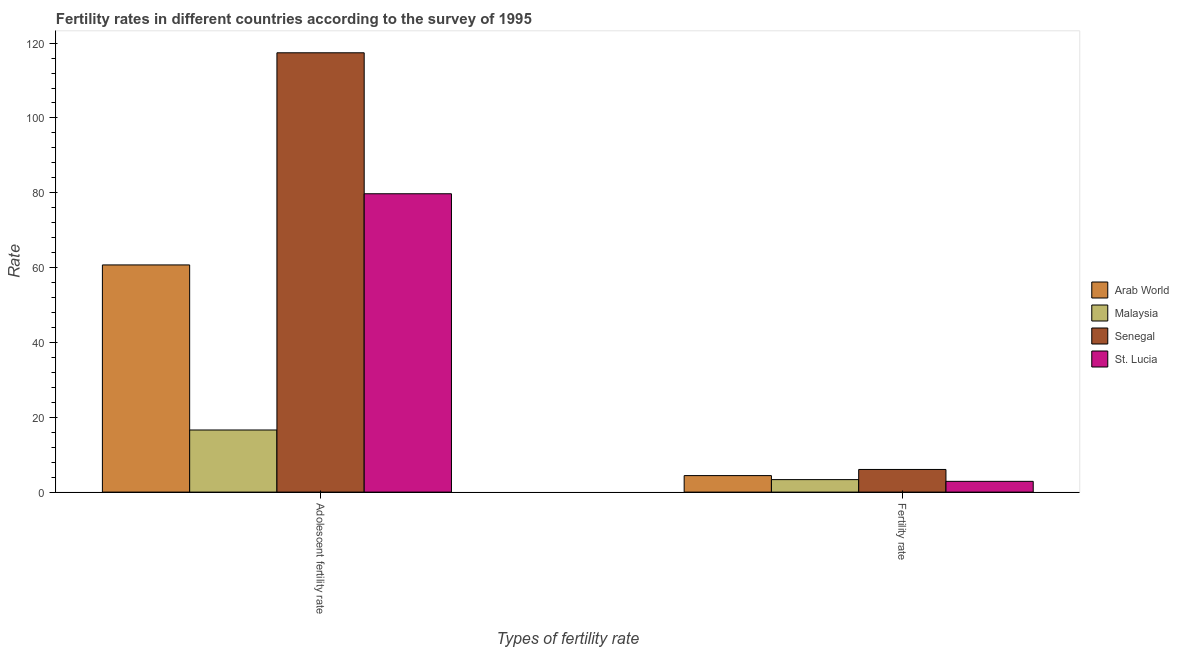How many groups of bars are there?
Your answer should be very brief. 2. Are the number of bars per tick equal to the number of legend labels?
Your answer should be very brief. Yes. How many bars are there on the 1st tick from the left?
Provide a short and direct response. 4. How many bars are there on the 1st tick from the right?
Offer a terse response. 4. What is the label of the 1st group of bars from the left?
Offer a terse response. Adolescent fertility rate. What is the adolescent fertility rate in Arab World?
Offer a very short reply. 60.72. Across all countries, what is the maximum fertility rate?
Offer a terse response. 6.05. Across all countries, what is the minimum adolescent fertility rate?
Make the answer very short. 16.6. In which country was the adolescent fertility rate maximum?
Ensure brevity in your answer.  Senegal. In which country was the fertility rate minimum?
Your response must be concise. St. Lucia. What is the total adolescent fertility rate in the graph?
Keep it short and to the point. 274.46. What is the difference between the adolescent fertility rate in St. Lucia and that in Malaysia?
Give a very brief answer. 63.13. What is the difference between the fertility rate in Senegal and the adolescent fertility rate in Malaysia?
Your answer should be compact. -10.55. What is the average fertility rate per country?
Give a very brief answer. 4.17. What is the difference between the adolescent fertility rate and fertility rate in St. Lucia?
Give a very brief answer. 76.86. In how many countries, is the fertility rate greater than 116 ?
Your answer should be compact. 0. What is the ratio of the fertility rate in Senegal to that in St. Lucia?
Make the answer very short. 2.11. In how many countries, is the adolescent fertility rate greater than the average adolescent fertility rate taken over all countries?
Keep it short and to the point. 2. What does the 2nd bar from the left in Fertility rate represents?
Offer a very short reply. Malaysia. What does the 2nd bar from the right in Fertility rate represents?
Provide a succinct answer. Senegal. How many bars are there?
Your answer should be compact. 8. Are all the bars in the graph horizontal?
Provide a short and direct response. No. How many countries are there in the graph?
Offer a terse response. 4. Does the graph contain any zero values?
Your answer should be very brief. No. Does the graph contain grids?
Your response must be concise. No. Where does the legend appear in the graph?
Provide a succinct answer. Center right. How many legend labels are there?
Provide a short and direct response. 4. What is the title of the graph?
Make the answer very short. Fertility rates in different countries according to the survey of 1995. Does "Equatorial Guinea" appear as one of the legend labels in the graph?
Your response must be concise. No. What is the label or title of the X-axis?
Provide a succinct answer. Types of fertility rate. What is the label or title of the Y-axis?
Your answer should be very brief. Rate. What is the Rate in Arab World in Adolescent fertility rate?
Provide a short and direct response. 60.72. What is the Rate of Malaysia in Adolescent fertility rate?
Keep it short and to the point. 16.6. What is the Rate in Senegal in Adolescent fertility rate?
Your answer should be compact. 117.41. What is the Rate in St. Lucia in Adolescent fertility rate?
Keep it short and to the point. 79.73. What is the Rate of Arab World in Fertility rate?
Your answer should be compact. 4.41. What is the Rate in Malaysia in Fertility rate?
Your answer should be very brief. 3.34. What is the Rate of Senegal in Fertility rate?
Your answer should be very brief. 6.05. What is the Rate in St. Lucia in Fertility rate?
Keep it short and to the point. 2.87. Across all Types of fertility rate, what is the maximum Rate in Arab World?
Make the answer very short. 60.72. Across all Types of fertility rate, what is the maximum Rate in Malaysia?
Offer a very short reply. 16.6. Across all Types of fertility rate, what is the maximum Rate in Senegal?
Offer a terse response. 117.41. Across all Types of fertility rate, what is the maximum Rate of St. Lucia?
Ensure brevity in your answer.  79.73. Across all Types of fertility rate, what is the minimum Rate in Arab World?
Offer a terse response. 4.41. Across all Types of fertility rate, what is the minimum Rate of Malaysia?
Your answer should be compact. 3.34. Across all Types of fertility rate, what is the minimum Rate of Senegal?
Keep it short and to the point. 6.05. Across all Types of fertility rate, what is the minimum Rate of St. Lucia?
Offer a terse response. 2.87. What is the total Rate of Arab World in the graph?
Provide a succinct answer. 65.12. What is the total Rate of Malaysia in the graph?
Ensure brevity in your answer.  19.94. What is the total Rate of Senegal in the graph?
Offer a terse response. 123.46. What is the total Rate in St. Lucia in the graph?
Offer a very short reply. 82.61. What is the difference between the Rate in Arab World in Adolescent fertility rate and that in Fertility rate?
Offer a terse response. 56.31. What is the difference between the Rate in Malaysia in Adolescent fertility rate and that in Fertility rate?
Your answer should be very brief. 13.26. What is the difference between the Rate of Senegal in Adolescent fertility rate and that in Fertility rate?
Provide a short and direct response. 111.36. What is the difference between the Rate in St. Lucia in Adolescent fertility rate and that in Fertility rate?
Provide a short and direct response. 76.86. What is the difference between the Rate in Arab World in Adolescent fertility rate and the Rate in Malaysia in Fertility rate?
Give a very brief answer. 57.38. What is the difference between the Rate in Arab World in Adolescent fertility rate and the Rate in Senegal in Fertility rate?
Provide a succinct answer. 54.66. What is the difference between the Rate of Arab World in Adolescent fertility rate and the Rate of St. Lucia in Fertility rate?
Offer a terse response. 57.84. What is the difference between the Rate of Malaysia in Adolescent fertility rate and the Rate of Senegal in Fertility rate?
Your answer should be very brief. 10.55. What is the difference between the Rate of Malaysia in Adolescent fertility rate and the Rate of St. Lucia in Fertility rate?
Provide a short and direct response. 13.73. What is the difference between the Rate in Senegal in Adolescent fertility rate and the Rate in St. Lucia in Fertility rate?
Make the answer very short. 114.54. What is the average Rate of Arab World per Types of fertility rate?
Provide a succinct answer. 32.56. What is the average Rate in Malaysia per Types of fertility rate?
Your answer should be very brief. 9.97. What is the average Rate in Senegal per Types of fertility rate?
Offer a very short reply. 61.73. What is the average Rate in St. Lucia per Types of fertility rate?
Your answer should be very brief. 41.3. What is the difference between the Rate in Arab World and Rate in Malaysia in Adolescent fertility rate?
Your response must be concise. 44.12. What is the difference between the Rate in Arab World and Rate in Senegal in Adolescent fertility rate?
Your response must be concise. -56.69. What is the difference between the Rate of Arab World and Rate of St. Lucia in Adolescent fertility rate?
Make the answer very short. -19.02. What is the difference between the Rate of Malaysia and Rate of Senegal in Adolescent fertility rate?
Your response must be concise. -100.81. What is the difference between the Rate in Malaysia and Rate in St. Lucia in Adolescent fertility rate?
Make the answer very short. -63.13. What is the difference between the Rate of Senegal and Rate of St. Lucia in Adolescent fertility rate?
Offer a very short reply. 37.68. What is the difference between the Rate in Arab World and Rate in Malaysia in Fertility rate?
Give a very brief answer. 1.07. What is the difference between the Rate of Arab World and Rate of Senegal in Fertility rate?
Your answer should be compact. -1.64. What is the difference between the Rate of Arab World and Rate of St. Lucia in Fertility rate?
Offer a terse response. 1.54. What is the difference between the Rate in Malaysia and Rate in Senegal in Fertility rate?
Keep it short and to the point. -2.71. What is the difference between the Rate of Malaysia and Rate of St. Lucia in Fertility rate?
Your answer should be compact. 0.47. What is the difference between the Rate in Senegal and Rate in St. Lucia in Fertility rate?
Keep it short and to the point. 3.18. What is the ratio of the Rate in Arab World in Adolescent fertility rate to that in Fertility rate?
Provide a short and direct response. 13.77. What is the ratio of the Rate in Malaysia in Adolescent fertility rate to that in Fertility rate?
Provide a succinct answer. 4.97. What is the ratio of the Rate of Senegal in Adolescent fertility rate to that in Fertility rate?
Your answer should be very brief. 19.4. What is the ratio of the Rate of St. Lucia in Adolescent fertility rate to that in Fertility rate?
Provide a succinct answer. 27.75. What is the difference between the highest and the second highest Rate in Arab World?
Provide a succinct answer. 56.31. What is the difference between the highest and the second highest Rate in Malaysia?
Provide a succinct answer. 13.26. What is the difference between the highest and the second highest Rate of Senegal?
Your answer should be very brief. 111.36. What is the difference between the highest and the second highest Rate in St. Lucia?
Offer a very short reply. 76.86. What is the difference between the highest and the lowest Rate of Arab World?
Your answer should be compact. 56.31. What is the difference between the highest and the lowest Rate of Malaysia?
Your response must be concise. 13.26. What is the difference between the highest and the lowest Rate in Senegal?
Offer a terse response. 111.36. What is the difference between the highest and the lowest Rate of St. Lucia?
Your answer should be compact. 76.86. 